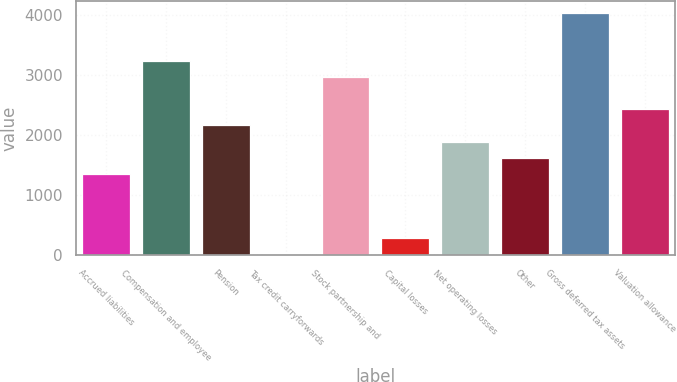<chart> <loc_0><loc_0><loc_500><loc_500><bar_chart><fcel>Accrued liabilities<fcel>Compensation and employee<fcel>Pension<fcel>Tax credit carryforwards<fcel>Stock partnership and<fcel>Capital losses<fcel>Net operating losses<fcel>Other<fcel>Gross deferred tax assets<fcel>Valuation allowance<nl><fcel>1355.6<fcel>3227.68<fcel>2157.92<fcel>18.4<fcel>2960.24<fcel>285.84<fcel>1890.48<fcel>1623.04<fcel>4030<fcel>2425.36<nl></chart> 